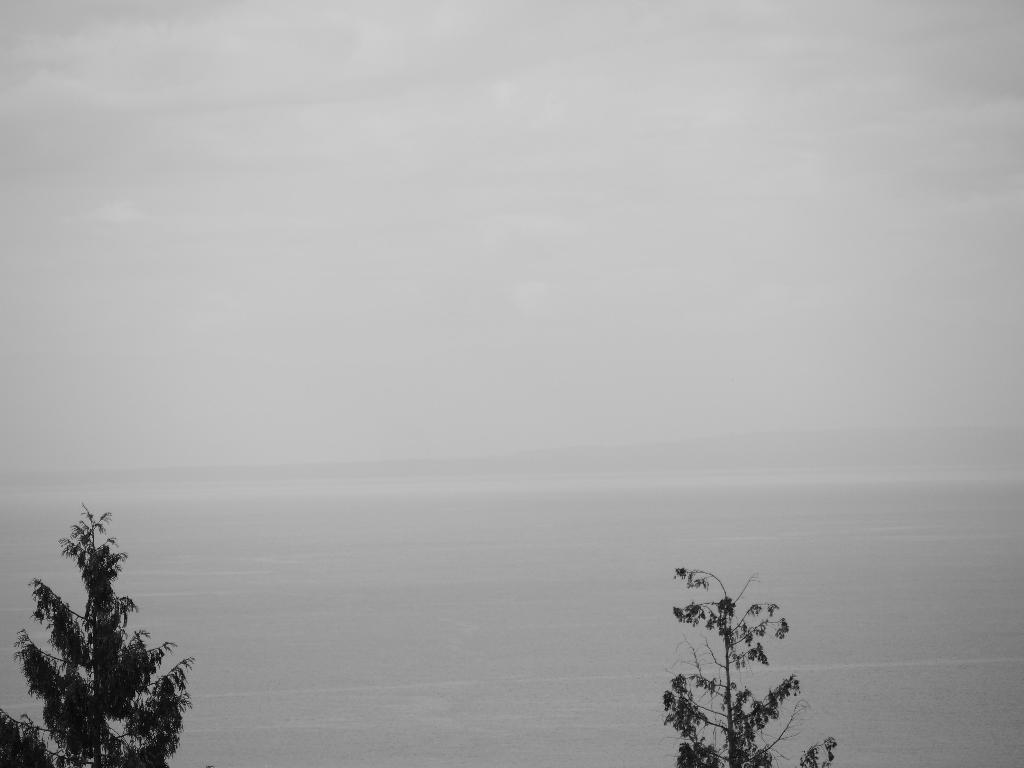What type of vegetation can be seen in the image? There are trees in the image. What is visible behind the trees in the image? There is a background visible in the image. What type of argument is taking place between the trees in the image? There is no argument present in the image; it only features trees and a background. 